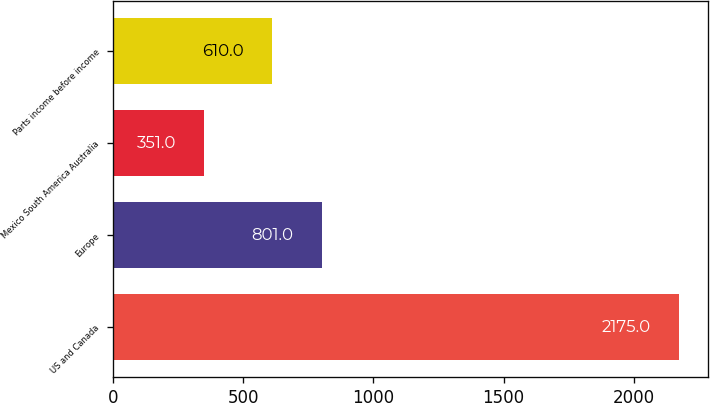<chart> <loc_0><loc_0><loc_500><loc_500><bar_chart><fcel>US and Canada<fcel>Europe<fcel>Mexico South America Australia<fcel>Parts income before income<nl><fcel>2175<fcel>801<fcel>351<fcel>610<nl></chart> 